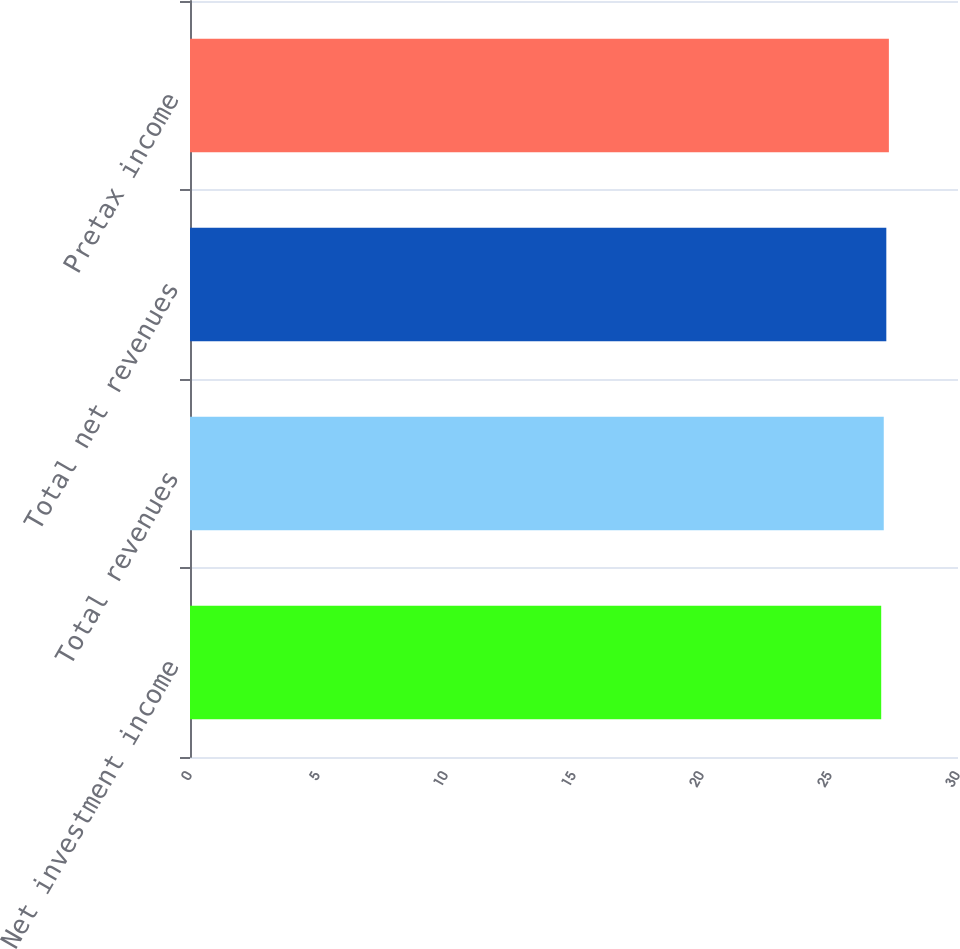Convert chart to OTSL. <chart><loc_0><loc_0><loc_500><loc_500><bar_chart><fcel>Net investment income<fcel>Total revenues<fcel>Total net revenues<fcel>Pretax income<nl><fcel>27<fcel>27.1<fcel>27.2<fcel>27.3<nl></chart> 